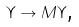<formula> <loc_0><loc_0><loc_500><loc_500>\Upsilon \to M \Upsilon \text {,}</formula> 